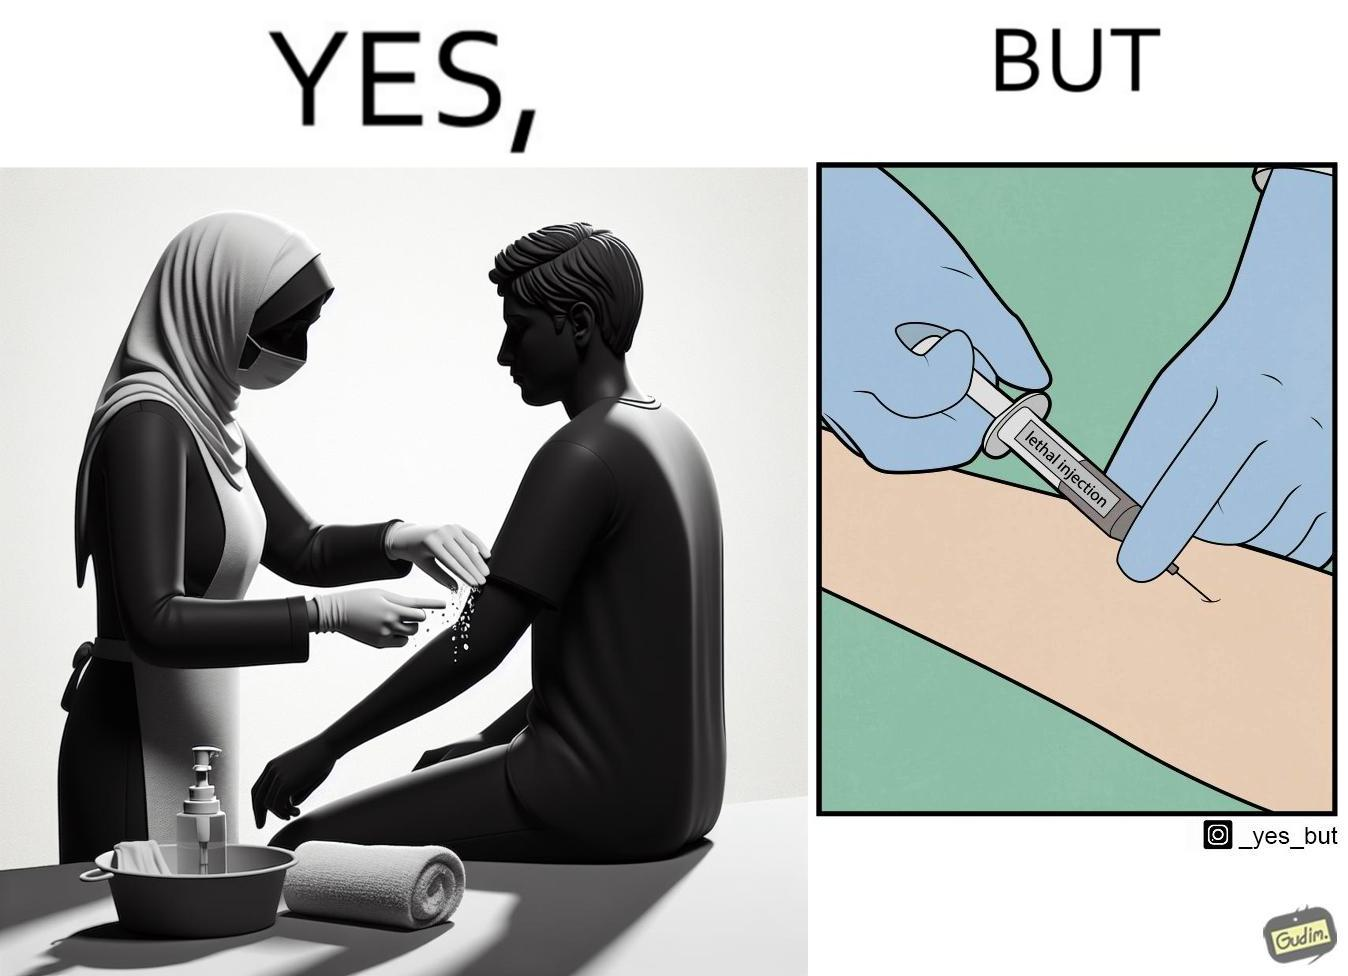Explain why this image is satirical. The image is ironical, as rubbing alcohol is used to clean a place on the arm for giving an injection, while the injection itself is 'lethal'. 